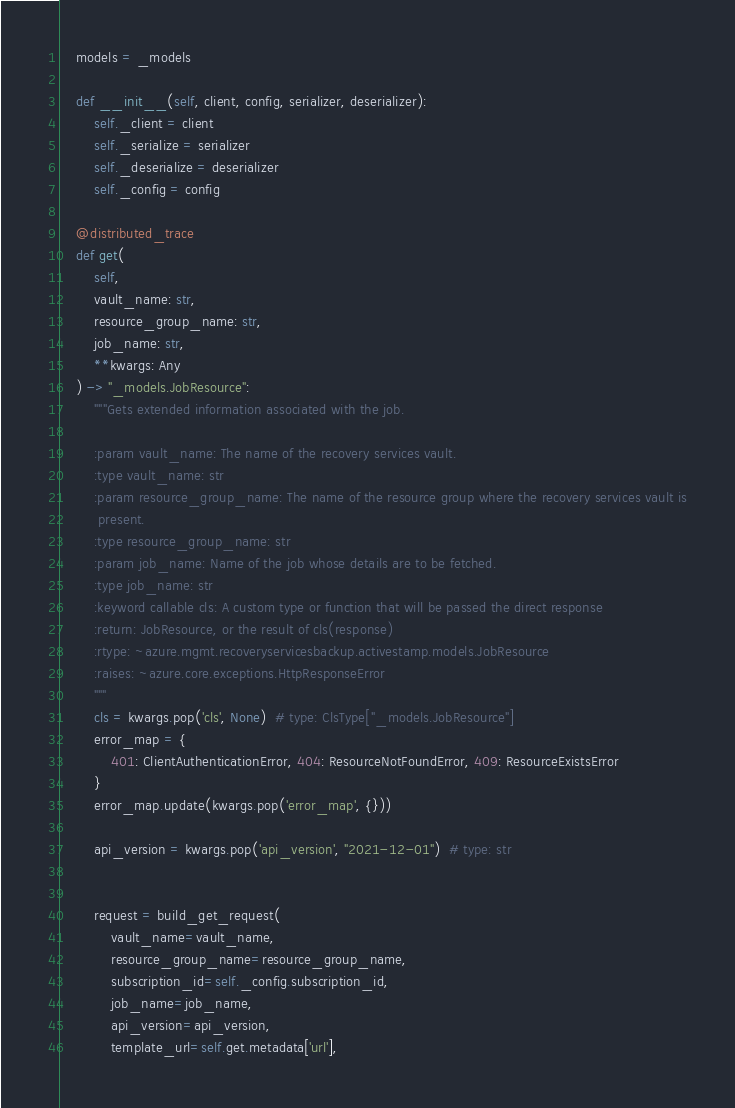Convert code to text. <code><loc_0><loc_0><loc_500><loc_500><_Python_>
    models = _models

    def __init__(self, client, config, serializer, deserializer):
        self._client = client
        self._serialize = serializer
        self._deserialize = deserializer
        self._config = config

    @distributed_trace
    def get(
        self,
        vault_name: str,
        resource_group_name: str,
        job_name: str,
        **kwargs: Any
    ) -> "_models.JobResource":
        """Gets extended information associated with the job.

        :param vault_name: The name of the recovery services vault.
        :type vault_name: str
        :param resource_group_name: The name of the resource group where the recovery services vault is
         present.
        :type resource_group_name: str
        :param job_name: Name of the job whose details are to be fetched.
        :type job_name: str
        :keyword callable cls: A custom type or function that will be passed the direct response
        :return: JobResource, or the result of cls(response)
        :rtype: ~azure.mgmt.recoveryservicesbackup.activestamp.models.JobResource
        :raises: ~azure.core.exceptions.HttpResponseError
        """
        cls = kwargs.pop('cls', None)  # type: ClsType["_models.JobResource"]
        error_map = {
            401: ClientAuthenticationError, 404: ResourceNotFoundError, 409: ResourceExistsError
        }
        error_map.update(kwargs.pop('error_map', {}))

        api_version = kwargs.pop('api_version', "2021-12-01")  # type: str

        
        request = build_get_request(
            vault_name=vault_name,
            resource_group_name=resource_group_name,
            subscription_id=self._config.subscription_id,
            job_name=job_name,
            api_version=api_version,
            template_url=self.get.metadata['url'],</code> 